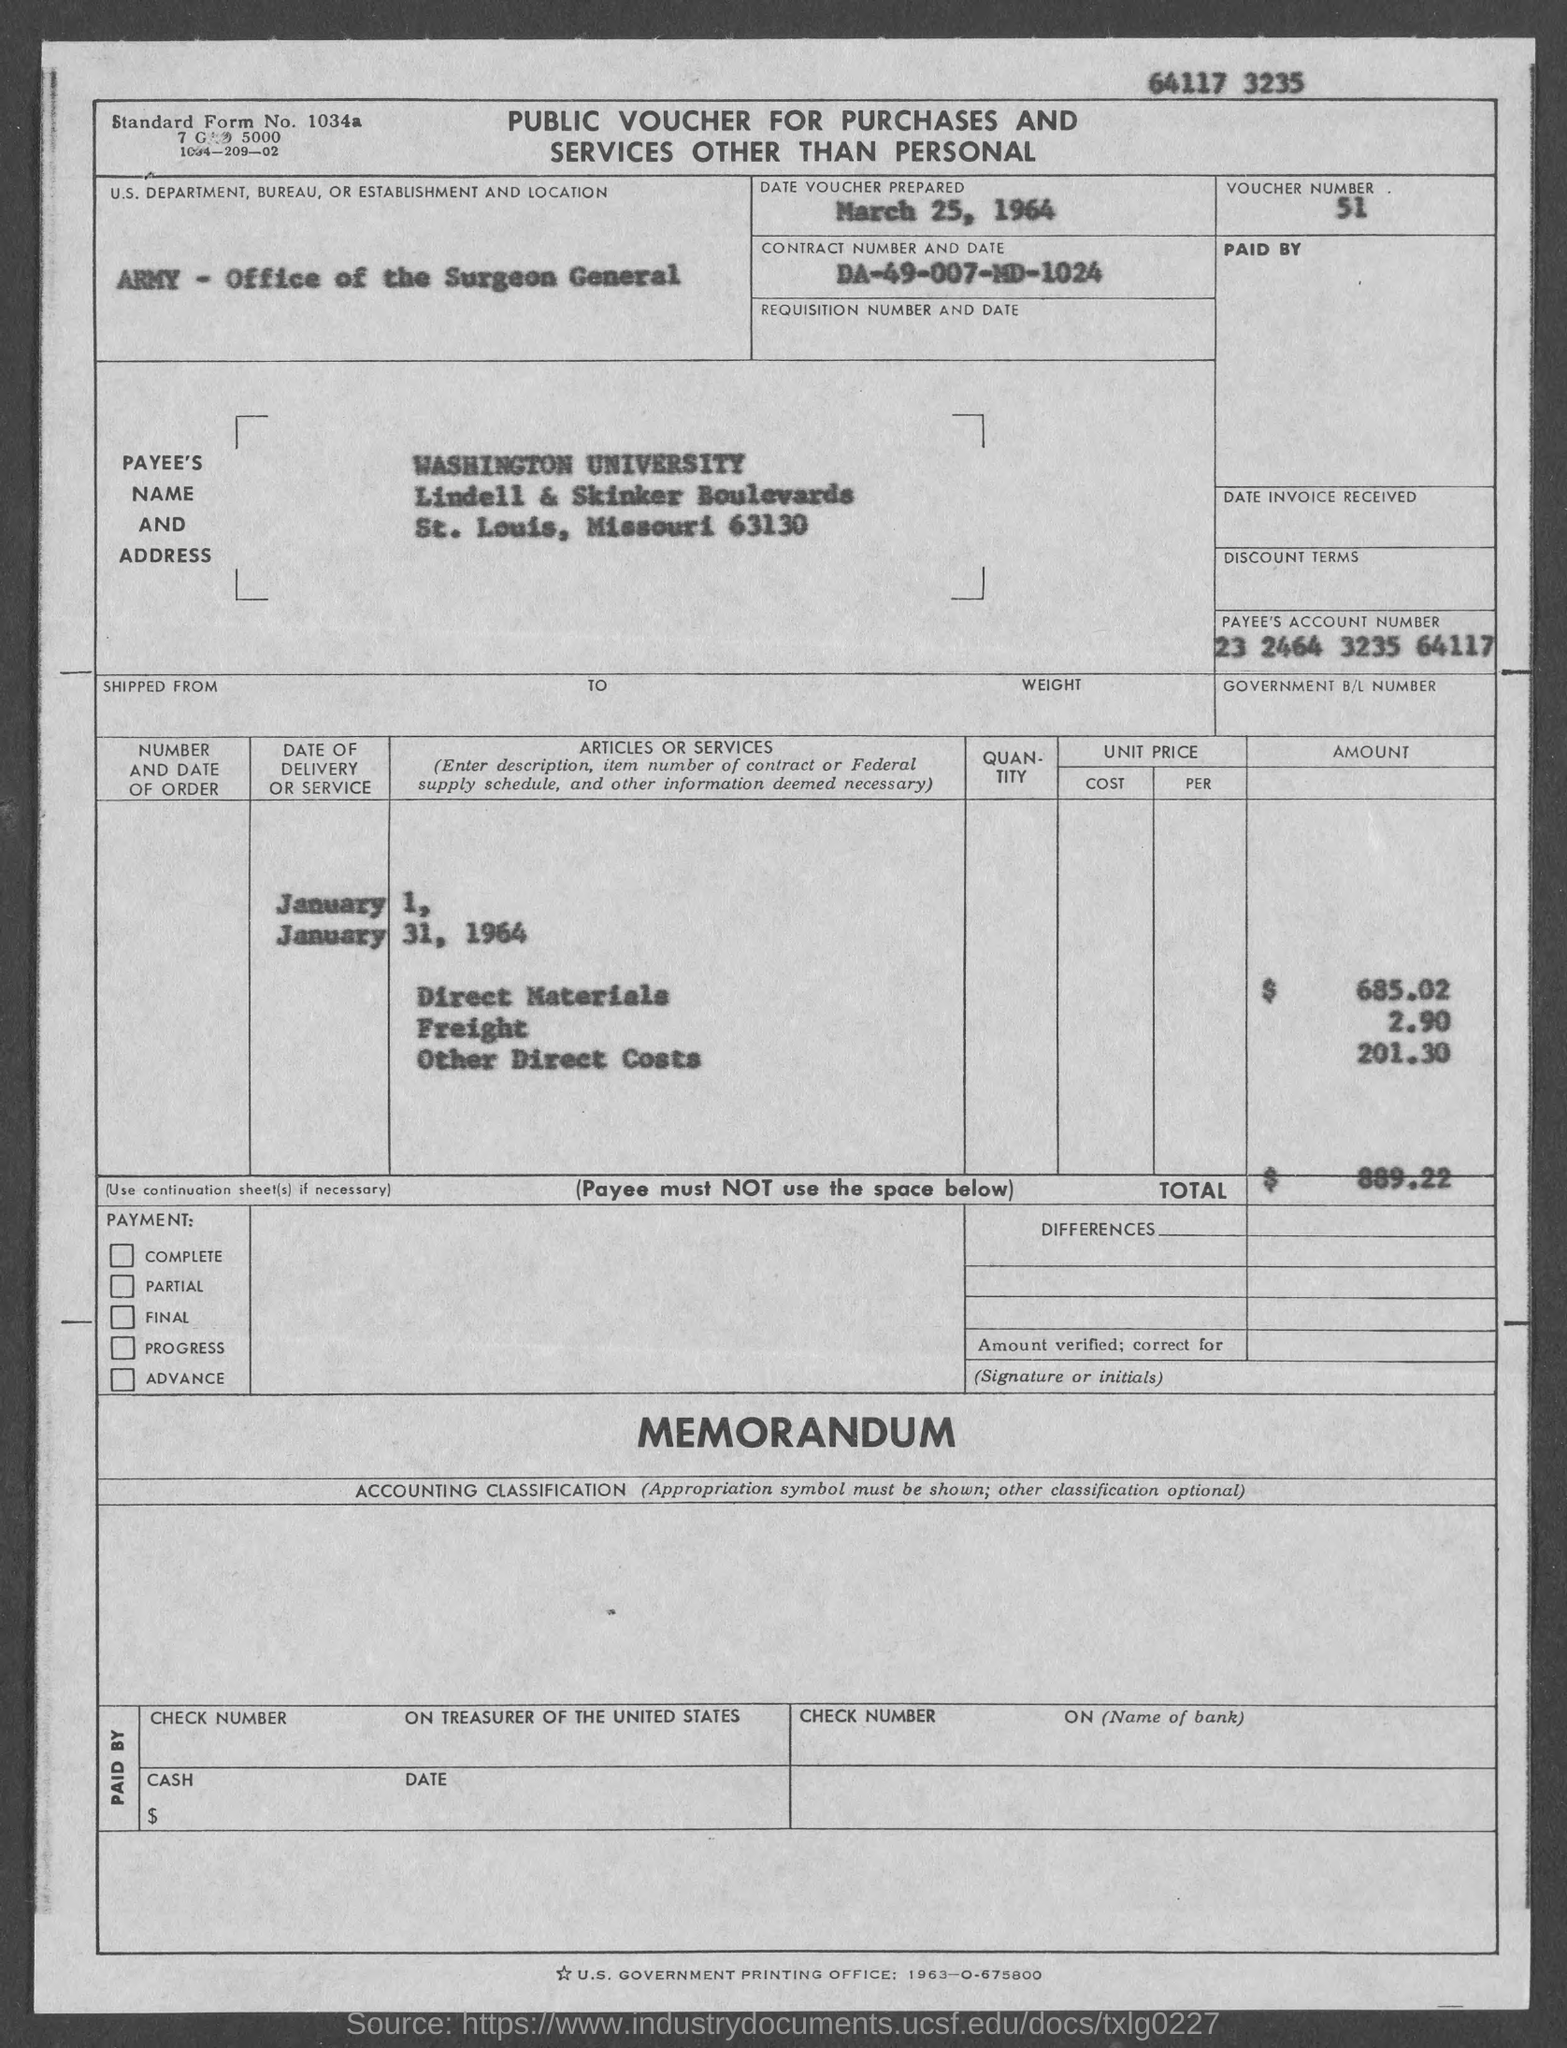What type of voucher is given here?
Your answer should be compact. PUBLIC VOUCHER FOR PURCHASES AND SERVICES OTHER THAN PERSONAL. What is the Standard Form No. given in the voucher?
Offer a terse response. 1034a. What is the voucher number given in the document?
Make the answer very short. 51. What is the date of voucher prepared?
Provide a short and direct response. March 25, 1964. What is the Contract No. given in the voucher?
Your answer should be compact. DA-49-007-MD-1024. What is the U.S. Department, Bureau, or Establishment given in the voucher?
Offer a terse response. Army - office of surgeon general. What is the Payee's Account No. given in the voucher?
Your response must be concise. 23 2464 3235 64117. What is the Direct material cost given in the voucher?
Keep it short and to the point. 685.02. What is the total voucher amount mentioned in the document?
Your answer should be very brief. 889.22. 